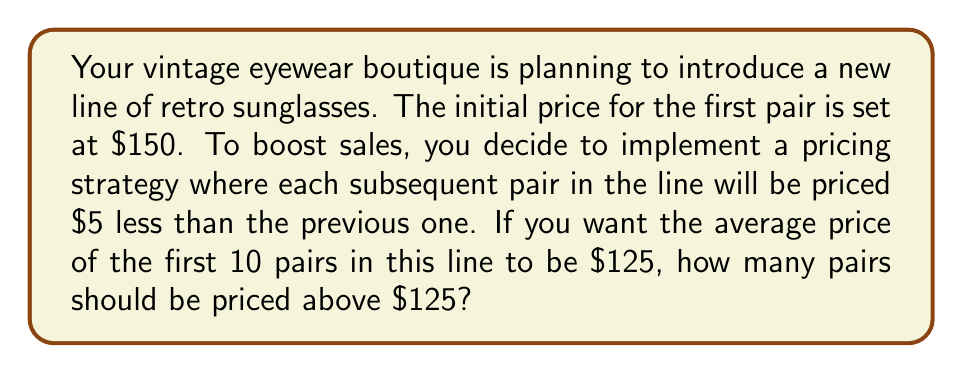What is the answer to this math problem? Let's approach this step-by-step using arithmetic sequences:

1) First, we need to identify the arithmetic sequence:
   $a_1 = 150$ (first term)
   $d = -5$ (common difference)

2) The nth term of an arithmetic sequence is given by:
   $a_n = a_1 + (n-1)d$

3) We need to find the sum of the first 10 terms, as we want the average of these to be $125:
   $S_{10} = \frac{n}{2}(a_1 + a_{10})$
   $S_{10} = 5(150 + a_{10})$

4) We know that the average should be $125, so:
   $\frac{S_{10}}{10} = 125$
   $S_{10} = 1250$

5) Substituting this into the equation from step 3:
   $1250 = 5(150 + a_{10})$
   $250 = 150 + a_{10}$
   $a_{10} = 100$

6) Now we can find n, the number of terms above $125:
   $125 = 150 + (n-1)(-5)$
   $125 = 150 - 5n + 5$
   $-30 = -5n$
   $n = 6$

Therefore, 6 pairs should be priced above $125.
Answer: 6 pairs 